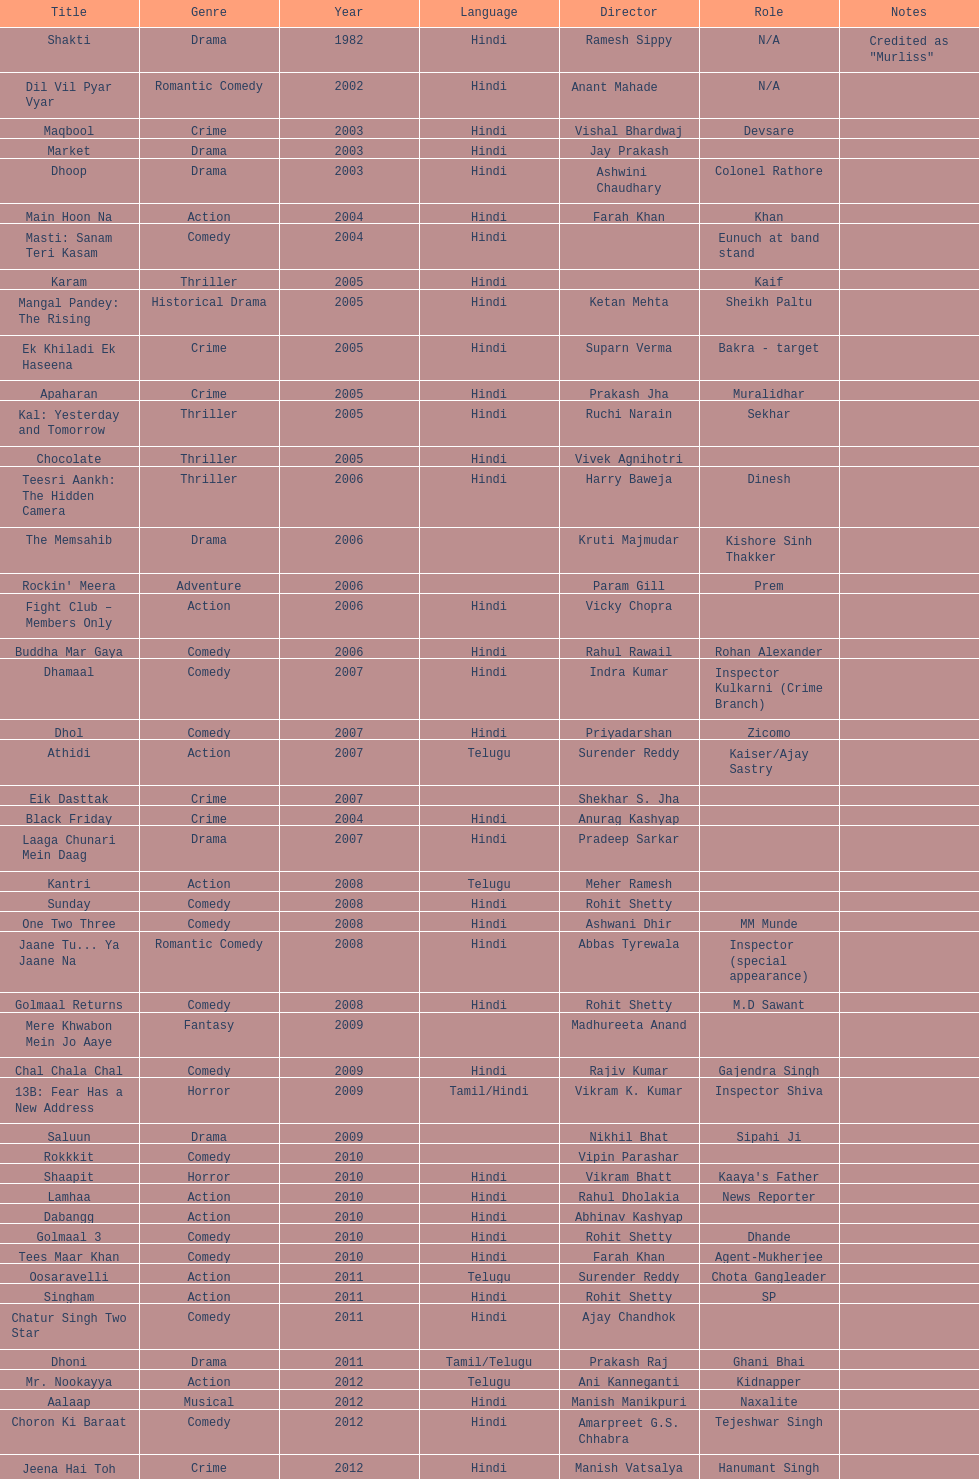What is the first language after hindi Telugu. 